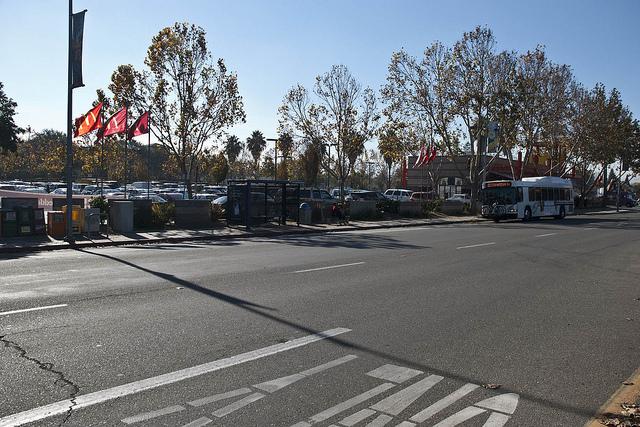Are the cars parked in front of an apartment complex?
Short answer required. No. Is it daytime?
Concise answer only. Yes. Is the parking lot full?
Write a very short answer. Yes. How can you tell if the wind is blowing?
Concise answer only. Flags moving. What is lining the street?
Write a very short answer. Flags. What color is the marking on the ground?
Be succinct. White. 